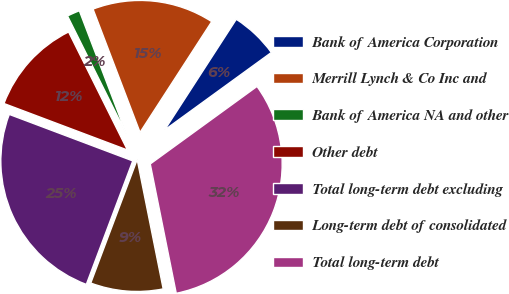<chart> <loc_0><loc_0><loc_500><loc_500><pie_chart><fcel>Bank of America Corporation<fcel>Merrill Lynch & Co Inc and<fcel>Bank of America NA and other<fcel>Other debt<fcel>Total long-term debt excluding<fcel>Long-term debt of consolidated<fcel>Total long-term debt<nl><fcel>5.86%<fcel>14.94%<fcel>1.56%<fcel>11.91%<fcel>25.01%<fcel>8.88%<fcel>31.84%<nl></chart> 